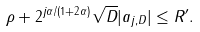<formula> <loc_0><loc_0><loc_500><loc_500>\rho + 2 ^ { j \alpha / ( 1 + 2 \alpha ) } \sqrt { D } | a _ { j , D } | \leq R ^ { \prime } .</formula> 